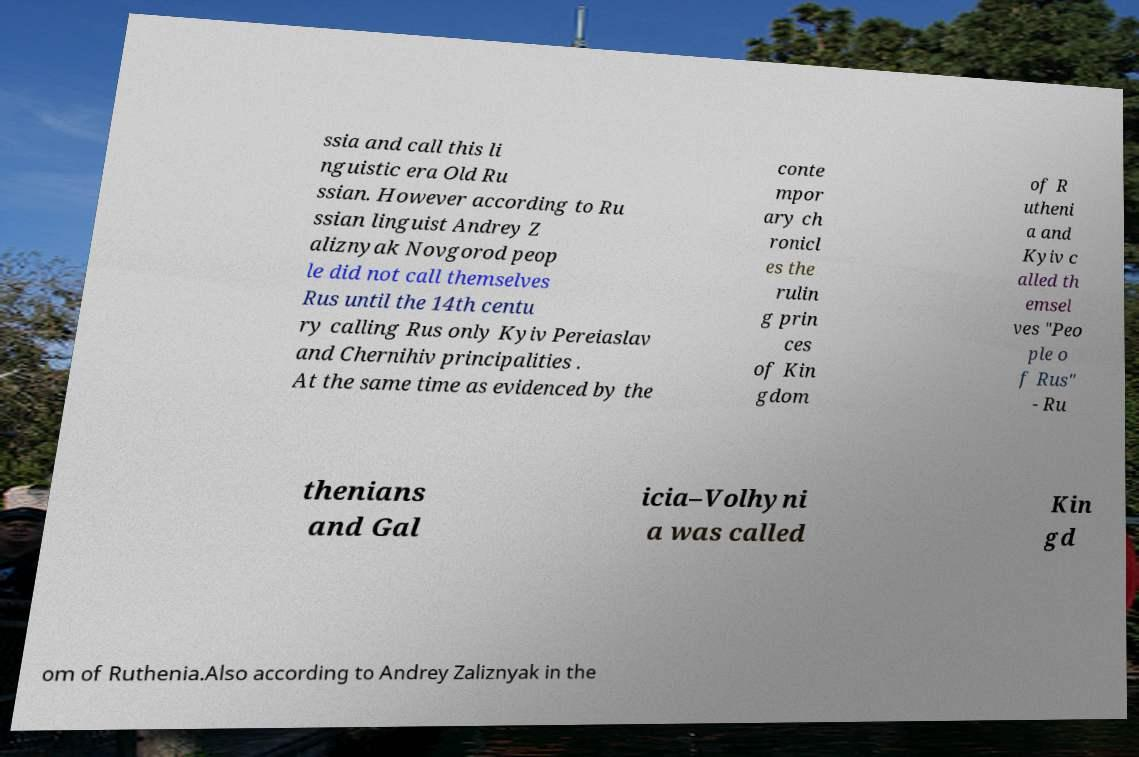Please read and relay the text visible in this image. What does it say? ssia and call this li nguistic era Old Ru ssian. However according to Ru ssian linguist Andrey Z aliznyak Novgorod peop le did not call themselves Rus until the 14th centu ry calling Rus only Kyiv Pereiaslav and Chernihiv principalities . At the same time as evidenced by the conte mpor ary ch ronicl es the rulin g prin ces of Kin gdom of R utheni a and Kyiv c alled th emsel ves "Peo ple o f Rus" - Ru thenians and Gal icia–Volhyni a was called Kin gd om of Ruthenia.Also according to Andrey Zaliznyak in the 